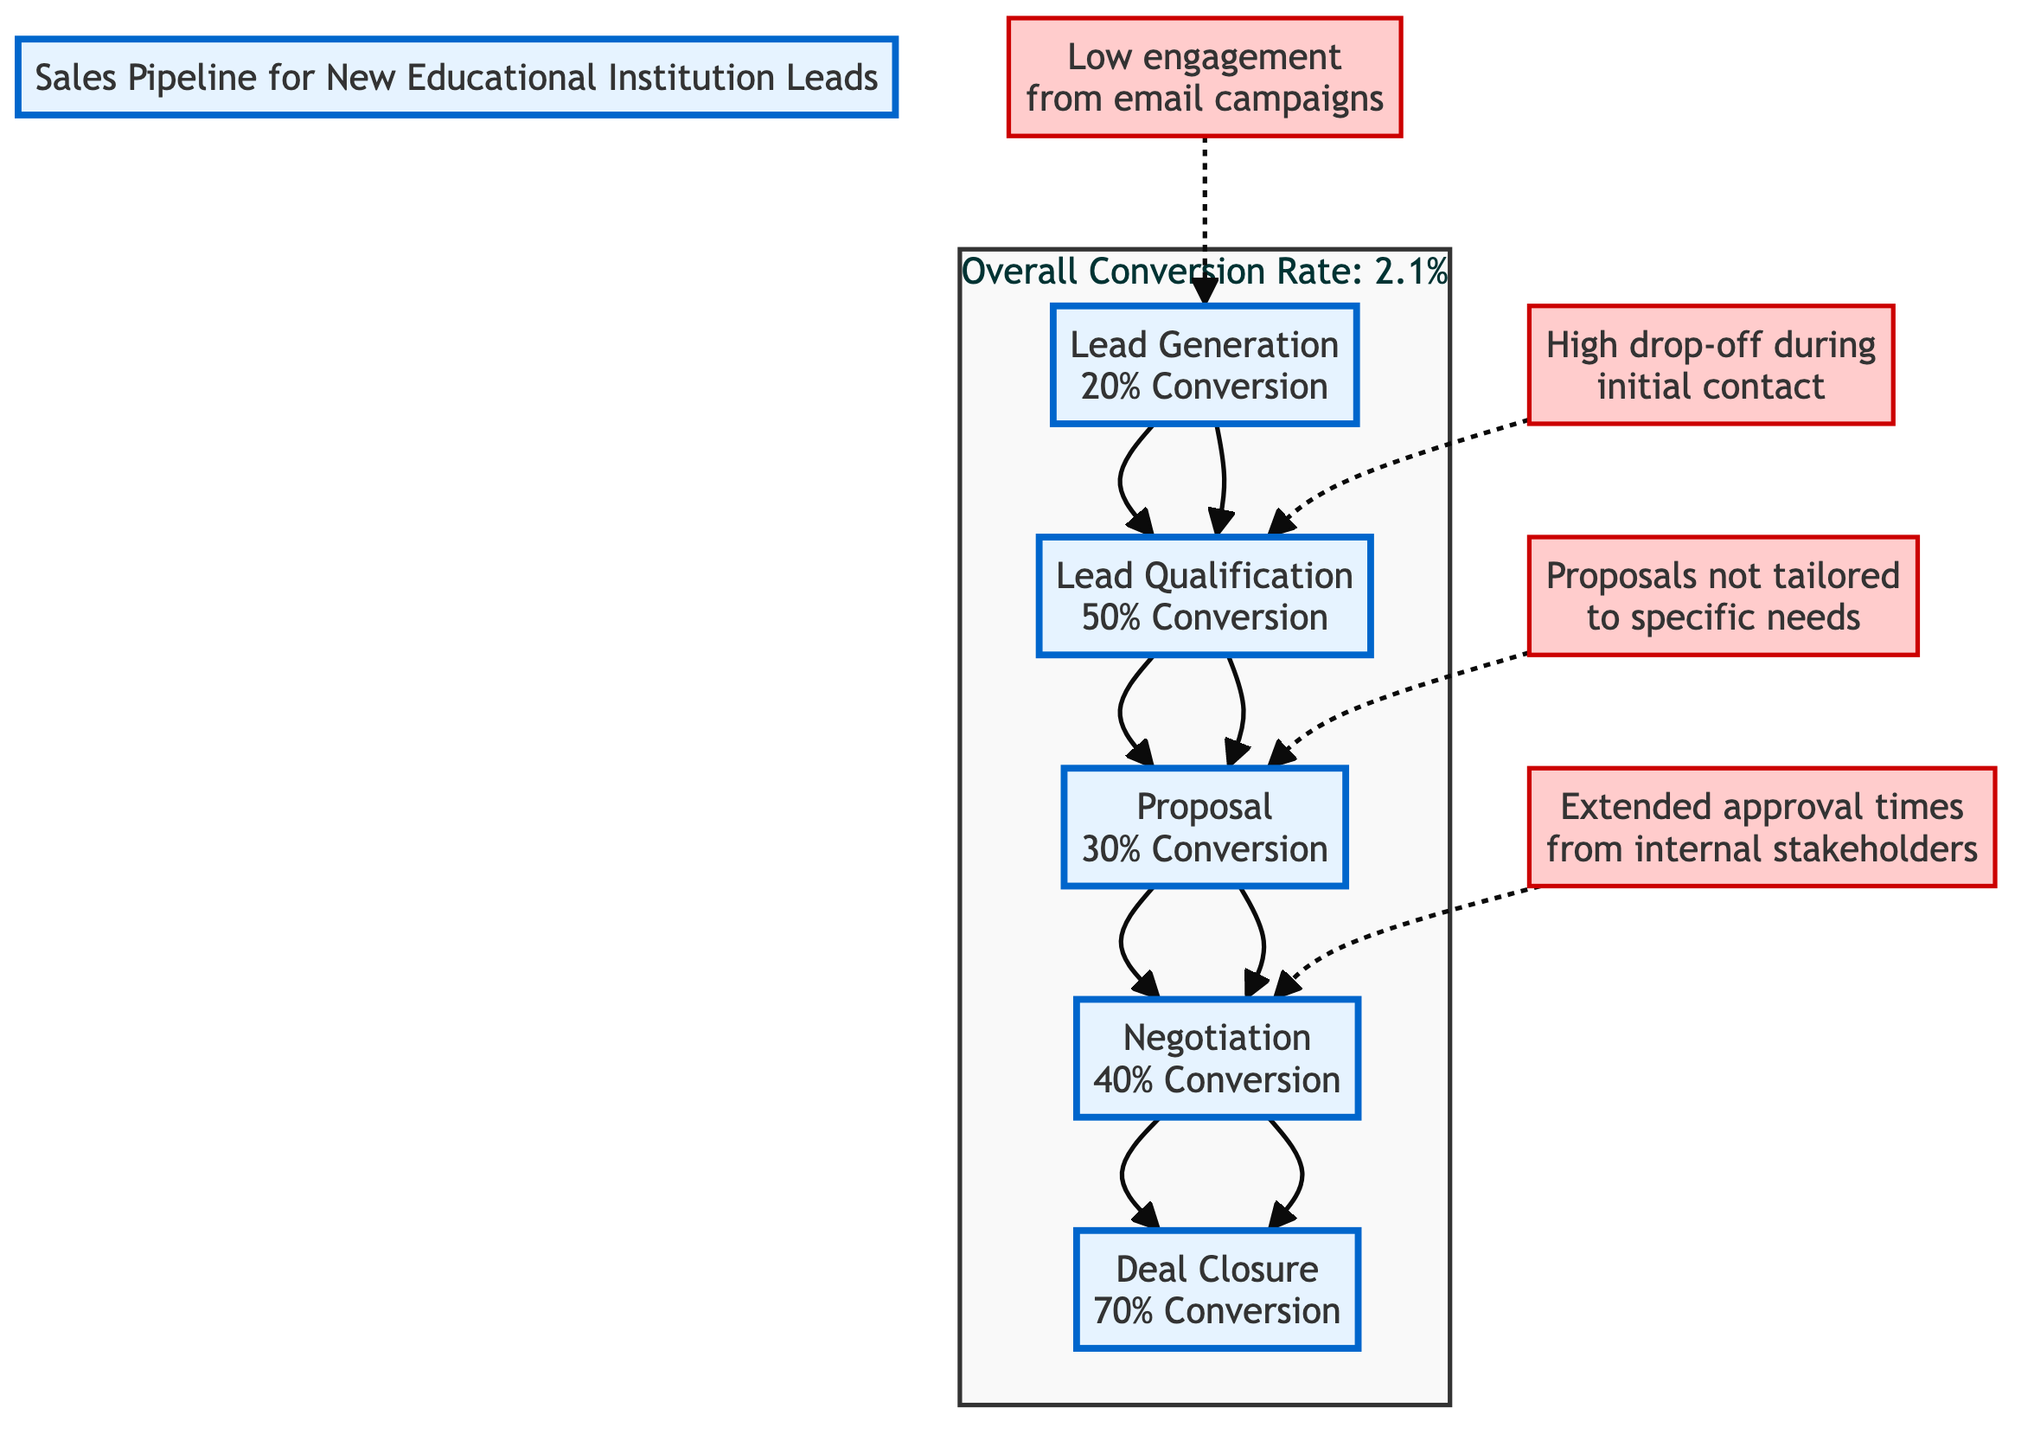What is the overall conversion rate depicted in the diagram? The diagram includes a subgraph labeled "Overall Conversion Rate" indicating a conversion rate of 2.1%.
Answer: 2.1% How many stages are there in the sales pipeline? The diagram shows five distinct stages: Lead Generation, Lead Qualification, Proposal, Negotiation, and Deal Closure, making a total of five stages.
Answer: 5 What is the conversion rate for the Proposal stage? The Proposal stage in the diagram states a conversion rate of 30%, as indicated in the node for Proposal.
Answer: 30% Which stage has the highest conversion rate? From the diagram's conversion rates, Deal Closure is noted to have the highest conversion rate at 70%.
Answer: 70% What bottleneck is associated with Lead Qualification? The diagram connects a low engagement issue from email campaigns as a bottleneck to the Lead Generation stage, but for Lead Qualification, it shows a high drop-off during the initial contact as the relevant bottleneck.
Answer: High drop-off during initial contact What is the relationship between Lead Generation and Lead Qualification? The diagram demonstrates a directional flow from Lead Generation to Lead Qualification, indicating that Lead Qualification follows after Lead Generation.
Answer: Lead Generation leads to Lead Qualification Which bottleneck affects the Negotiation stage? The diagram identifies "Extended approval times from internal stakeholders" as a bottleneck that impacts the Negotiation stage directly.
Answer: Extended approval times from internal stakeholders What conversion rate is associated with the Lead Generation stage? The Lead Generation stage is noted to have a conversion rate of 20% indicated directly in the respective node.
Answer: 20% What does the bottleneck "Proposals not tailored to specific needs" refer to? This bottleneck impacts the Proposal stage, suggesting that proposals are not effectively customized for the potential educational institutions, creating a bottleneck in the sales process.
Answer: Proposals not tailored to specific needs What does the arrow represent between the stages in the sales pipeline? The arrows in the diagram represent the flow and progression from one stage to the next within the sales pipeline, indicating the sequential movement from lead generation to deal closure.
Answer: Flow of progression 